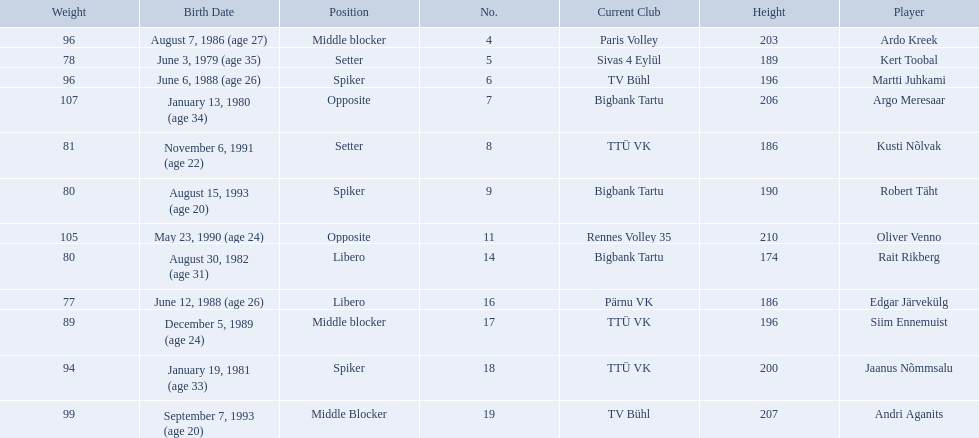Who are all of the players? Ardo Kreek, Kert Toobal, Martti Juhkami, Argo Meresaar, Kusti Nõlvak, Robert Täht, Oliver Venno, Rait Rikberg, Edgar Järvekülg, Siim Ennemuist, Jaanus Nõmmsalu, Andri Aganits. How tall are they? 203, 189, 196, 206, 186, 190, 210, 174, 186, 196, 200, 207. And which player is tallest? Oliver Venno. What are the heights in cm of the men on the team? 203, 189, 196, 206, 186, 190, 210, 174, 186, 196, 200, 207. What is the tallest height of a team member? 210. Which player stands at 210? Oliver Venno. 